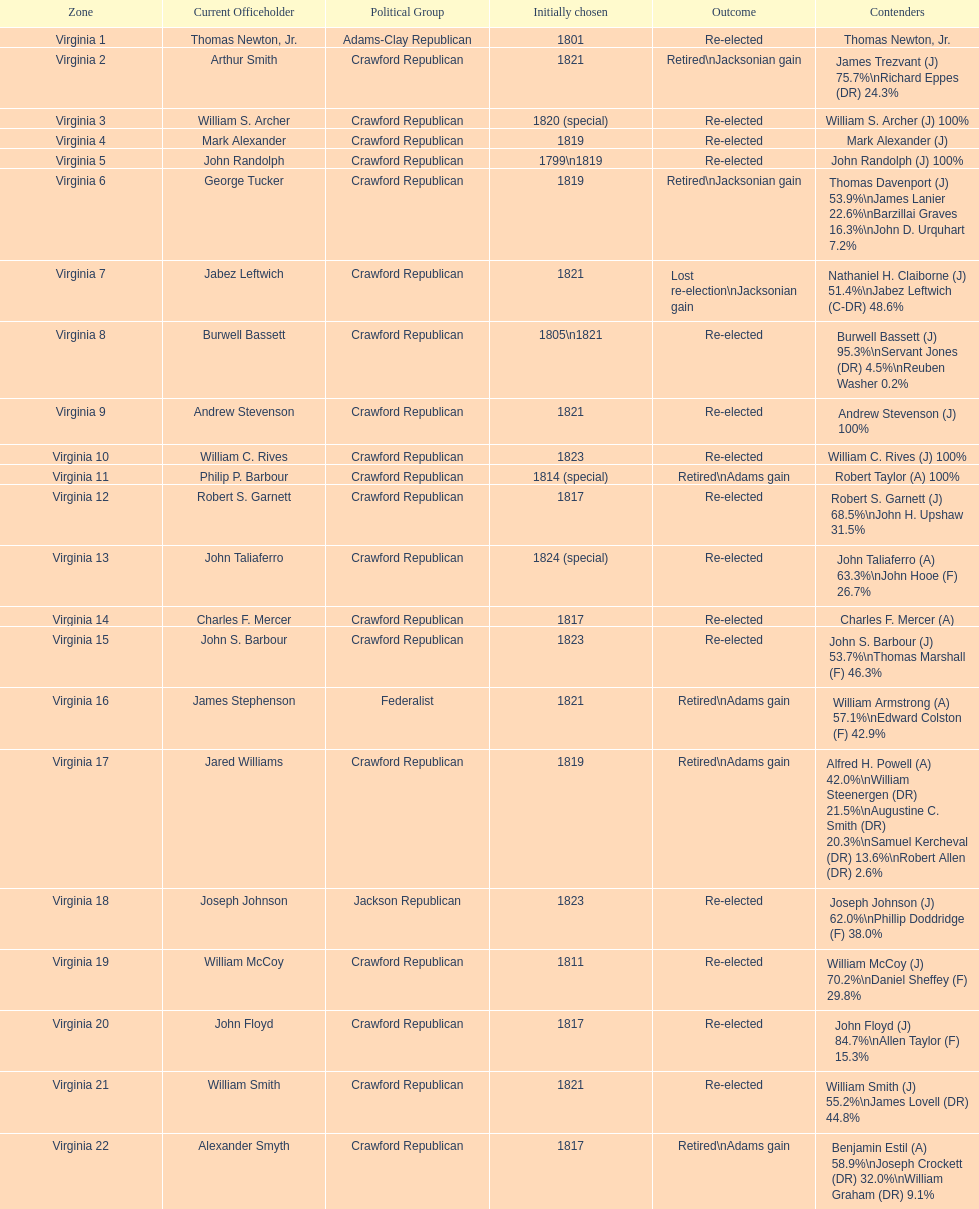What are the number of times re-elected is listed as the result? 15. 